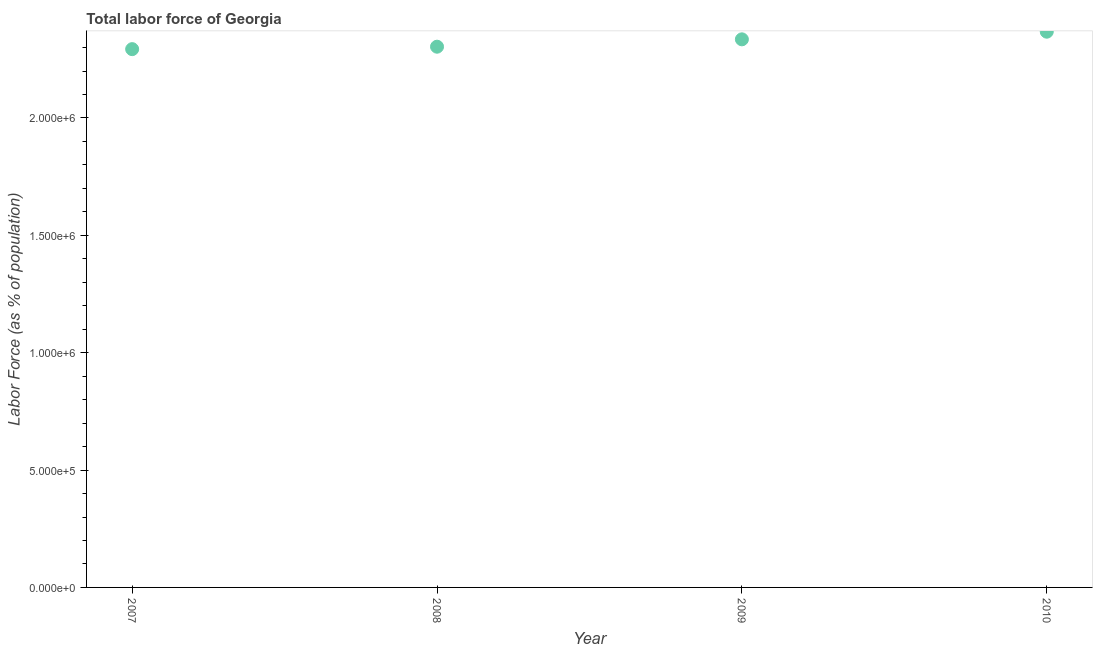What is the total labor force in 2007?
Offer a terse response. 2.29e+06. Across all years, what is the maximum total labor force?
Offer a very short reply. 2.37e+06. Across all years, what is the minimum total labor force?
Your answer should be compact. 2.29e+06. What is the sum of the total labor force?
Offer a very short reply. 9.30e+06. What is the difference between the total labor force in 2007 and 2009?
Your answer should be very brief. -4.18e+04. What is the average total labor force per year?
Your answer should be compact. 2.32e+06. What is the median total labor force?
Offer a very short reply. 2.32e+06. What is the ratio of the total labor force in 2007 to that in 2009?
Keep it short and to the point. 0.98. Is the total labor force in 2007 less than that in 2010?
Offer a terse response. Yes. Is the difference between the total labor force in 2007 and 2010 greater than the difference between any two years?
Your answer should be very brief. Yes. What is the difference between the highest and the second highest total labor force?
Provide a short and direct response. 3.25e+04. What is the difference between the highest and the lowest total labor force?
Offer a terse response. 7.43e+04. How many dotlines are there?
Ensure brevity in your answer.  1. What is the title of the graph?
Make the answer very short. Total labor force of Georgia. What is the label or title of the X-axis?
Your answer should be very brief. Year. What is the label or title of the Y-axis?
Offer a very short reply. Labor Force (as % of population). What is the Labor Force (as % of population) in 2007?
Offer a terse response. 2.29e+06. What is the Labor Force (as % of population) in 2008?
Make the answer very short. 2.30e+06. What is the Labor Force (as % of population) in 2009?
Your response must be concise. 2.33e+06. What is the Labor Force (as % of population) in 2010?
Give a very brief answer. 2.37e+06. What is the difference between the Labor Force (as % of population) in 2007 and 2008?
Offer a very short reply. -1.04e+04. What is the difference between the Labor Force (as % of population) in 2007 and 2009?
Make the answer very short. -4.18e+04. What is the difference between the Labor Force (as % of population) in 2007 and 2010?
Provide a short and direct response. -7.43e+04. What is the difference between the Labor Force (as % of population) in 2008 and 2009?
Offer a terse response. -3.14e+04. What is the difference between the Labor Force (as % of population) in 2008 and 2010?
Your answer should be very brief. -6.39e+04. What is the difference between the Labor Force (as % of population) in 2009 and 2010?
Provide a succinct answer. -3.25e+04. What is the ratio of the Labor Force (as % of population) in 2007 to that in 2008?
Your response must be concise. 0.99. What is the ratio of the Labor Force (as % of population) in 2008 to that in 2010?
Keep it short and to the point. 0.97. What is the ratio of the Labor Force (as % of population) in 2009 to that in 2010?
Make the answer very short. 0.99. 